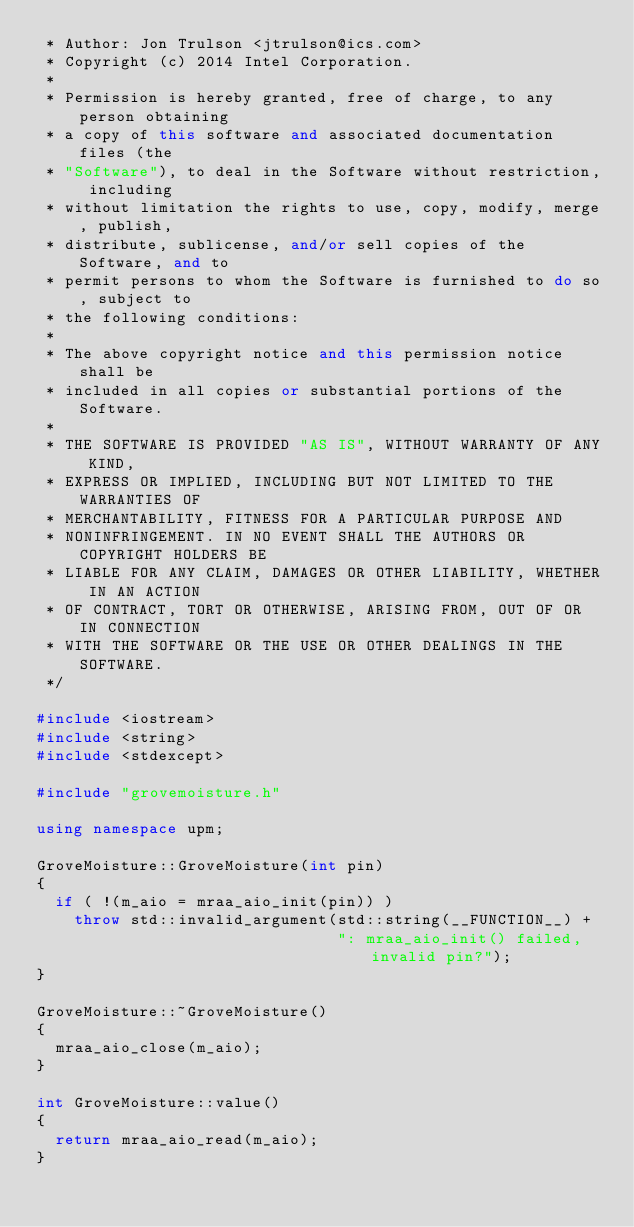<code> <loc_0><loc_0><loc_500><loc_500><_C++_> * Author: Jon Trulson <jtrulson@ics.com>
 * Copyright (c) 2014 Intel Corporation.
 *
 * Permission is hereby granted, free of charge, to any person obtaining
 * a copy of this software and associated documentation files (the
 * "Software"), to deal in the Software without restriction, including
 * without limitation the rights to use, copy, modify, merge, publish,
 * distribute, sublicense, and/or sell copies of the Software, and to
 * permit persons to whom the Software is furnished to do so, subject to
 * the following conditions:
 *
 * The above copyright notice and this permission notice shall be
 * included in all copies or substantial portions of the Software.
 *
 * THE SOFTWARE IS PROVIDED "AS IS", WITHOUT WARRANTY OF ANY KIND,
 * EXPRESS OR IMPLIED, INCLUDING BUT NOT LIMITED TO THE WARRANTIES OF
 * MERCHANTABILITY, FITNESS FOR A PARTICULAR PURPOSE AND
 * NONINFRINGEMENT. IN NO EVENT SHALL THE AUTHORS OR COPYRIGHT HOLDERS BE
 * LIABLE FOR ANY CLAIM, DAMAGES OR OTHER LIABILITY, WHETHER IN AN ACTION
 * OF CONTRACT, TORT OR OTHERWISE, ARISING FROM, OUT OF OR IN CONNECTION
 * WITH THE SOFTWARE OR THE USE OR OTHER DEALINGS IN THE SOFTWARE.
 */

#include <iostream>
#include <string>
#include <stdexcept>

#include "grovemoisture.h"

using namespace upm;

GroveMoisture::GroveMoisture(int pin)
{
  if ( !(m_aio = mraa_aio_init(pin)) )
    throw std::invalid_argument(std::string(__FUNCTION__) +
                                ": mraa_aio_init() failed, invalid pin?");
}

GroveMoisture::~GroveMoisture()
{
  mraa_aio_close(m_aio);
}

int GroveMoisture::value()
{
  return mraa_aio_read(m_aio);
}
</code> 